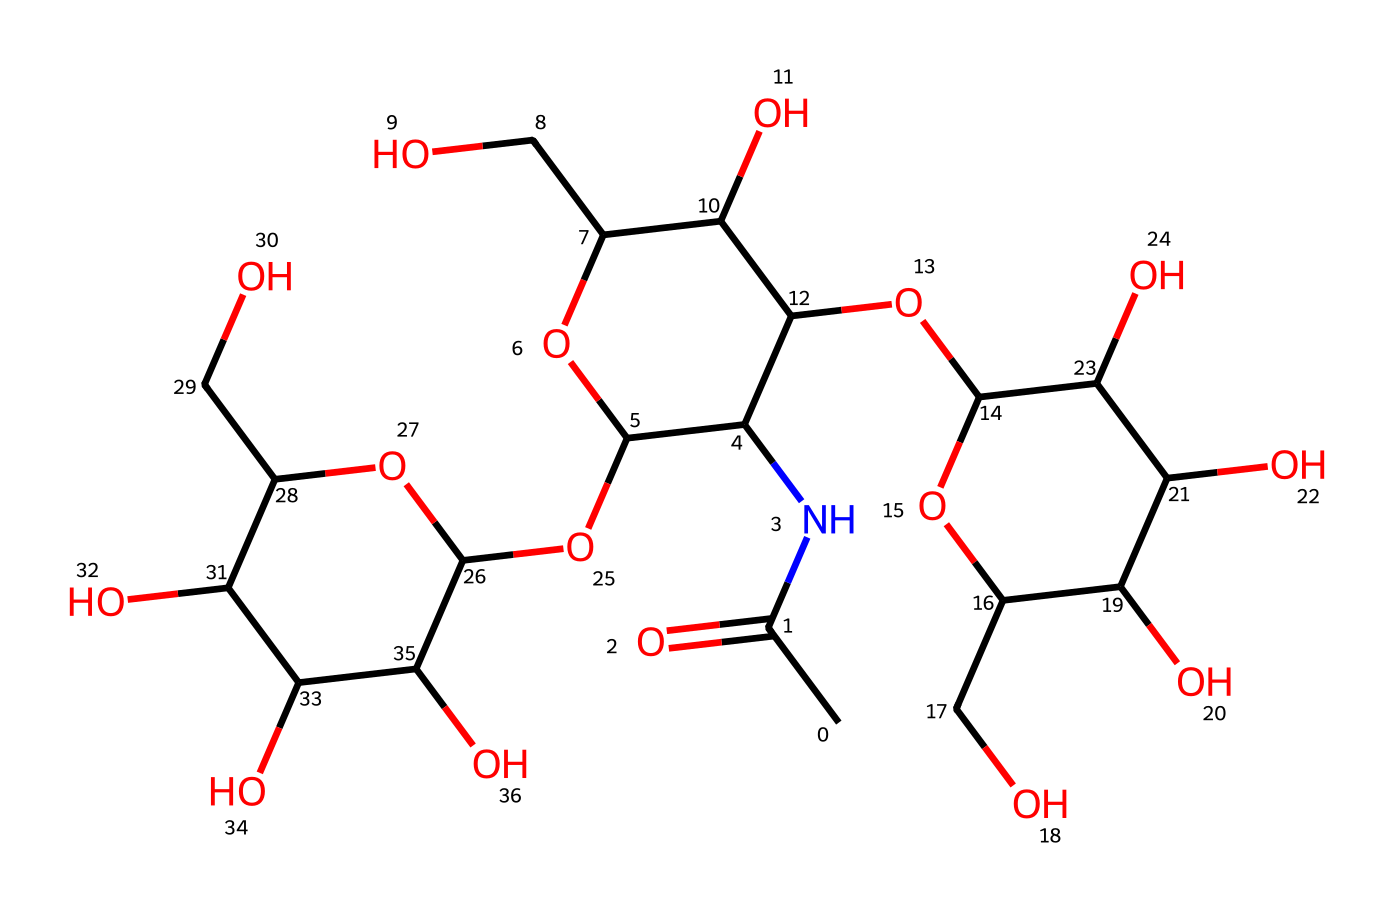What is the molecular formula of this compound? By analyzing the chemical structure, we can determine the molecular formula based on the number of each type of atom present. The compound consists of carbon (C), hydrogen (H), nitrogen (N), and oxygen (O). Summarizing the different types of atoms yields the empirical molecular formula, C15H27N1O13.
Answer: C15H27N1O13 How many oxygen atoms are present in this structure? Counting the number of oxygen atoms in the chemical structure, we find that there are 13 oxygen atoms linked in various parts of the structure.
Answer: 13 What type of chemical bond primarily connects the atoms in hyaluronic acid? The structure consists of covalent bonds, which are formed by the sharing of electrons between the atoms present. The connections that make up the backbone and functional groups of hyaluronic acid are typical of covalent bond formations.
Answer: covalent What role does nitrogen play in this compound? The nitrogen atom in the structure likely indicates the presence of an amide functional group, which plays a key role in enhancing the hydrophilicity of the molecule and assisting in moisture retention. This is particularly relevant in the context of hydrating sports recovery creams.
Answer: moisturizing Is hyaluronic acid more likely to be hydrophobic or hydrophilic? Given the presence of multiple hydroxyl (–OH) groups due to the 13 oxygen atoms, the chemical structure indicates a strong tendency toward hydrophilicity. These functions are responsible for attracting water molecules, making hyaluronic acid a well-known hydrating agent.
Answer: hydrophilic 